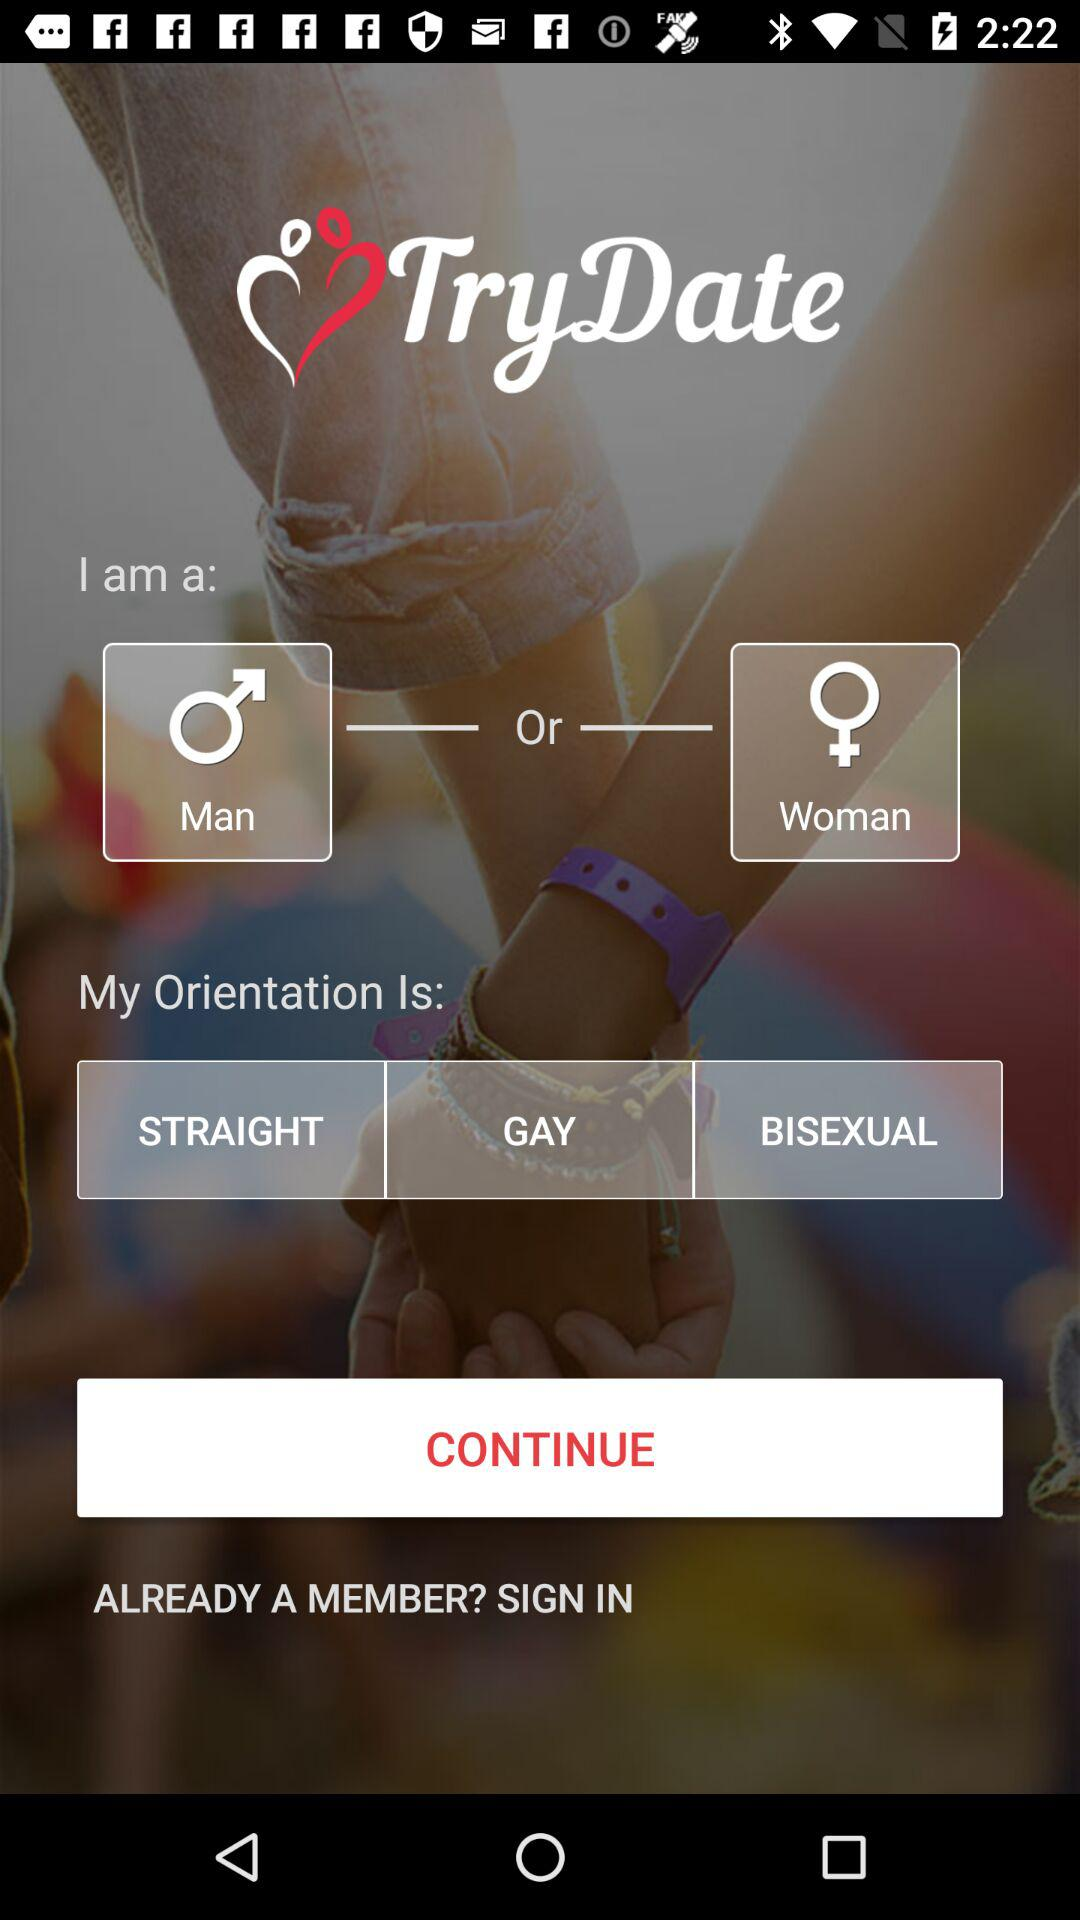What are the options in "My Orientation"? The options in "My Orientation" are "STRAIGHT", "GAY" and "BISEXUAL". 